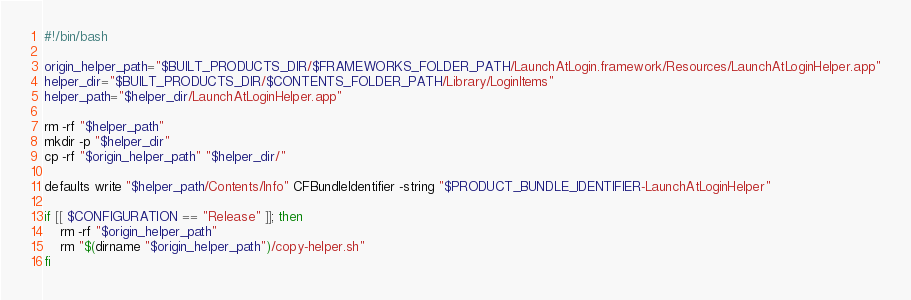Convert code to text. <code><loc_0><loc_0><loc_500><loc_500><_Bash_>#!/bin/bash

origin_helper_path="$BUILT_PRODUCTS_DIR/$FRAMEWORKS_FOLDER_PATH/LaunchAtLogin.framework/Resources/LaunchAtLoginHelper.app"
helper_dir="$BUILT_PRODUCTS_DIR/$CONTENTS_FOLDER_PATH/Library/LoginItems"
helper_path="$helper_dir/LaunchAtLoginHelper.app"

rm -rf "$helper_path"
mkdir -p "$helper_dir"
cp -rf "$origin_helper_path" "$helper_dir/"

defaults write "$helper_path/Contents/Info" CFBundleIdentifier -string "$PRODUCT_BUNDLE_IDENTIFIER-LaunchAtLoginHelper"

if [[ $CONFIGURATION == "Release" ]]; then
	rm -rf "$origin_helper_path"
	rm "$(dirname "$origin_helper_path")/copy-helper.sh"
fi
</code> 